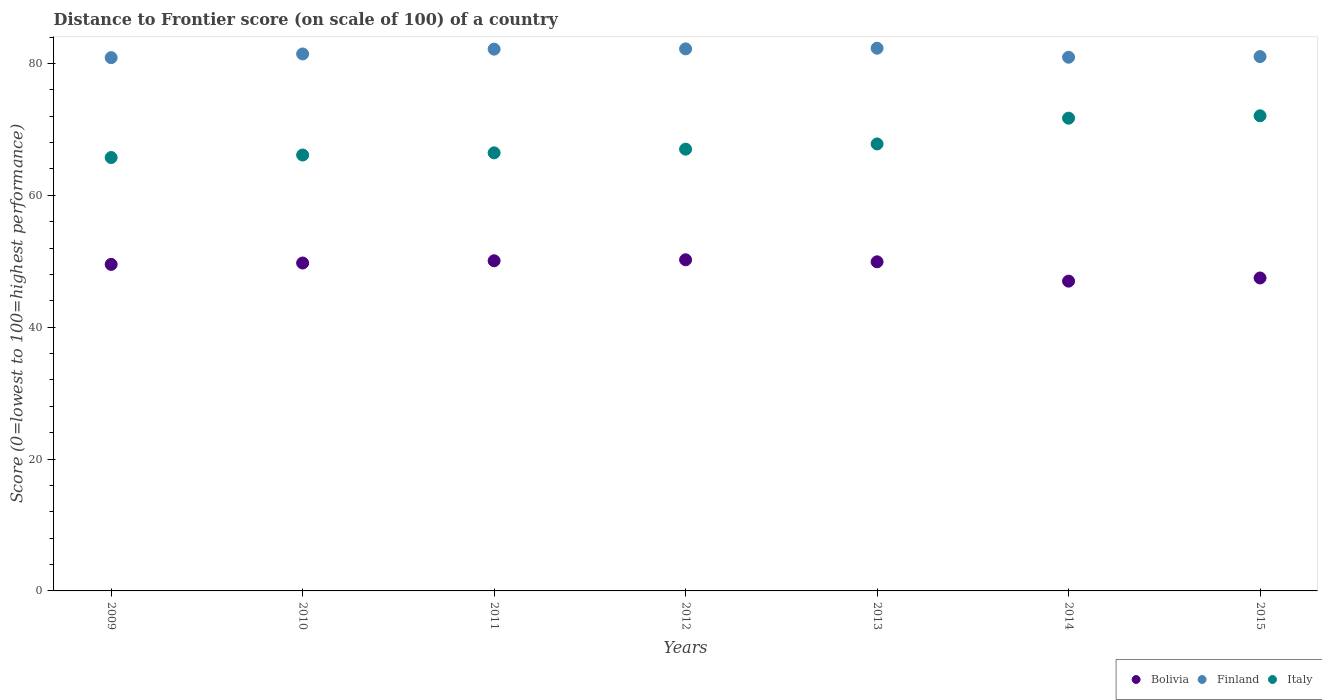What is the distance to frontier score of in Bolivia in 2010?
Make the answer very short. 49.74. Across all years, what is the maximum distance to frontier score of in Italy?
Provide a short and direct response. 72.07. Across all years, what is the minimum distance to frontier score of in Bolivia?
Provide a succinct answer. 46.99. In which year was the distance to frontier score of in Bolivia maximum?
Provide a short and direct response. 2012. In which year was the distance to frontier score of in Bolivia minimum?
Keep it short and to the point. 2014. What is the total distance to frontier score of in Italy in the graph?
Ensure brevity in your answer.  476.9. What is the difference between the distance to frontier score of in Italy in 2009 and that in 2015?
Make the answer very short. -6.33. What is the difference between the distance to frontier score of in Finland in 2012 and the distance to frontier score of in Bolivia in 2009?
Provide a short and direct response. 32.69. What is the average distance to frontier score of in Finland per year?
Keep it short and to the point. 81.58. In the year 2009, what is the difference between the distance to frontier score of in Bolivia and distance to frontier score of in Italy?
Make the answer very short. -16.21. What is the ratio of the distance to frontier score of in Italy in 2010 to that in 2014?
Provide a short and direct response. 0.92. Is the distance to frontier score of in Bolivia in 2011 less than that in 2013?
Your answer should be compact. No. Is the difference between the distance to frontier score of in Bolivia in 2009 and 2015 greater than the difference between the distance to frontier score of in Italy in 2009 and 2015?
Give a very brief answer. Yes. What is the difference between the highest and the second highest distance to frontier score of in Bolivia?
Offer a terse response. 0.15. What is the difference between the highest and the lowest distance to frontier score of in Italy?
Keep it short and to the point. 6.33. In how many years, is the distance to frontier score of in Italy greater than the average distance to frontier score of in Italy taken over all years?
Make the answer very short. 2. Is it the case that in every year, the sum of the distance to frontier score of in Finland and distance to frontier score of in Bolivia  is greater than the distance to frontier score of in Italy?
Offer a very short reply. Yes. Does the distance to frontier score of in Italy monotonically increase over the years?
Your answer should be very brief. Yes. How many dotlines are there?
Give a very brief answer. 3. How many years are there in the graph?
Provide a succinct answer. 7. What is the difference between two consecutive major ticks on the Y-axis?
Provide a succinct answer. 20. Are the values on the major ticks of Y-axis written in scientific E-notation?
Offer a terse response. No. Does the graph contain any zero values?
Your answer should be compact. No. How many legend labels are there?
Keep it short and to the point. 3. What is the title of the graph?
Your answer should be very brief. Distance to Frontier score (on scale of 100) of a country. Does "Guam" appear as one of the legend labels in the graph?
Offer a very short reply. No. What is the label or title of the X-axis?
Keep it short and to the point. Years. What is the label or title of the Y-axis?
Provide a succinct answer. Score (0=lowest to 100=highest performance). What is the Score (0=lowest to 100=highest performance) of Bolivia in 2009?
Provide a short and direct response. 49.53. What is the Score (0=lowest to 100=highest performance) of Finland in 2009?
Your response must be concise. 80.89. What is the Score (0=lowest to 100=highest performance) in Italy in 2009?
Your response must be concise. 65.74. What is the Score (0=lowest to 100=highest performance) in Bolivia in 2010?
Provide a short and direct response. 49.74. What is the Score (0=lowest to 100=highest performance) in Finland in 2010?
Your answer should be very brief. 81.45. What is the Score (0=lowest to 100=highest performance) of Italy in 2010?
Provide a succinct answer. 66.12. What is the Score (0=lowest to 100=highest performance) in Bolivia in 2011?
Your answer should be very brief. 50.08. What is the Score (0=lowest to 100=highest performance) in Finland in 2011?
Your answer should be compact. 82.18. What is the Score (0=lowest to 100=highest performance) in Italy in 2011?
Offer a terse response. 66.45. What is the Score (0=lowest to 100=highest performance) of Bolivia in 2012?
Your answer should be compact. 50.23. What is the Score (0=lowest to 100=highest performance) of Finland in 2012?
Offer a terse response. 82.22. What is the Score (0=lowest to 100=highest performance) in Italy in 2012?
Your response must be concise. 67.01. What is the Score (0=lowest to 100=highest performance) in Bolivia in 2013?
Your response must be concise. 49.92. What is the Score (0=lowest to 100=highest performance) in Finland in 2013?
Offer a very short reply. 82.32. What is the Score (0=lowest to 100=highest performance) of Italy in 2013?
Your answer should be compact. 67.8. What is the Score (0=lowest to 100=highest performance) of Bolivia in 2014?
Provide a succinct answer. 46.99. What is the Score (0=lowest to 100=highest performance) in Finland in 2014?
Offer a terse response. 80.95. What is the Score (0=lowest to 100=highest performance) of Italy in 2014?
Offer a very short reply. 71.71. What is the Score (0=lowest to 100=highest performance) of Bolivia in 2015?
Make the answer very short. 47.47. What is the Score (0=lowest to 100=highest performance) of Finland in 2015?
Your answer should be very brief. 81.05. What is the Score (0=lowest to 100=highest performance) in Italy in 2015?
Ensure brevity in your answer.  72.07. Across all years, what is the maximum Score (0=lowest to 100=highest performance) in Bolivia?
Your answer should be very brief. 50.23. Across all years, what is the maximum Score (0=lowest to 100=highest performance) in Finland?
Provide a short and direct response. 82.32. Across all years, what is the maximum Score (0=lowest to 100=highest performance) in Italy?
Ensure brevity in your answer.  72.07. Across all years, what is the minimum Score (0=lowest to 100=highest performance) of Bolivia?
Provide a succinct answer. 46.99. Across all years, what is the minimum Score (0=lowest to 100=highest performance) of Finland?
Offer a terse response. 80.89. Across all years, what is the minimum Score (0=lowest to 100=highest performance) of Italy?
Ensure brevity in your answer.  65.74. What is the total Score (0=lowest to 100=highest performance) of Bolivia in the graph?
Your response must be concise. 343.96. What is the total Score (0=lowest to 100=highest performance) of Finland in the graph?
Provide a succinct answer. 571.06. What is the total Score (0=lowest to 100=highest performance) of Italy in the graph?
Provide a short and direct response. 476.9. What is the difference between the Score (0=lowest to 100=highest performance) of Bolivia in 2009 and that in 2010?
Provide a succinct answer. -0.21. What is the difference between the Score (0=lowest to 100=highest performance) in Finland in 2009 and that in 2010?
Provide a short and direct response. -0.56. What is the difference between the Score (0=lowest to 100=highest performance) in Italy in 2009 and that in 2010?
Offer a terse response. -0.38. What is the difference between the Score (0=lowest to 100=highest performance) of Bolivia in 2009 and that in 2011?
Offer a very short reply. -0.55. What is the difference between the Score (0=lowest to 100=highest performance) in Finland in 2009 and that in 2011?
Offer a very short reply. -1.29. What is the difference between the Score (0=lowest to 100=highest performance) in Italy in 2009 and that in 2011?
Make the answer very short. -0.71. What is the difference between the Score (0=lowest to 100=highest performance) of Finland in 2009 and that in 2012?
Your answer should be compact. -1.33. What is the difference between the Score (0=lowest to 100=highest performance) of Italy in 2009 and that in 2012?
Your answer should be very brief. -1.27. What is the difference between the Score (0=lowest to 100=highest performance) in Bolivia in 2009 and that in 2013?
Ensure brevity in your answer.  -0.39. What is the difference between the Score (0=lowest to 100=highest performance) in Finland in 2009 and that in 2013?
Give a very brief answer. -1.43. What is the difference between the Score (0=lowest to 100=highest performance) in Italy in 2009 and that in 2013?
Provide a short and direct response. -2.06. What is the difference between the Score (0=lowest to 100=highest performance) in Bolivia in 2009 and that in 2014?
Your answer should be compact. 2.54. What is the difference between the Score (0=lowest to 100=highest performance) of Finland in 2009 and that in 2014?
Give a very brief answer. -0.06. What is the difference between the Score (0=lowest to 100=highest performance) in Italy in 2009 and that in 2014?
Keep it short and to the point. -5.97. What is the difference between the Score (0=lowest to 100=highest performance) in Bolivia in 2009 and that in 2015?
Provide a succinct answer. 2.06. What is the difference between the Score (0=lowest to 100=highest performance) of Finland in 2009 and that in 2015?
Ensure brevity in your answer.  -0.16. What is the difference between the Score (0=lowest to 100=highest performance) in Italy in 2009 and that in 2015?
Make the answer very short. -6.33. What is the difference between the Score (0=lowest to 100=highest performance) in Bolivia in 2010 and that in 2011?
Ensure brevity in your answer.  -0.34. What is the difference between the Score (0=lowest to 100=highest performance) in Finland in 2010 and that in 2011?
Your answer should be very brief. -0.73. What is the difference between the Score (0=lowest to 100=highest performance) of Italy in 2010 and that in 2011?
Keep it short and to the point. -0.33. What is the difference between the Score (0=lowest to 100=highest performance) of Bolivia in 2010 and that in 2012?
Ensure brevity in your answer.  -0.49. What is the difference between the Score (0=lowest to 100=highest performance) in Finland in 2010 and that in 2012?
Your response must be concise. -0.77. What is the difference between the Score (0=lowest to 100=highest performance) in Italy in 2010 and that in 2012?
Keep it short and to the point. -0.89. What is the difference between the Score (0=lowest to 100=highest performance) in Bolivia in 2010 and that in 2013?
Your answer should be very brief. -0.18. What is the difference between the Score (0=lowest to 100=highest performance) of Finland in 2010 and that in 2013?
Your answer should be very brief. -0.87. What is the difference between the Score (0=lowest to 100=highest performance) in Italy in 2010 and that in 2013?
Make the answer very short. -1.68. What is the difference between the Score (0=lowest to 100=highest performance) in Bolivia in 2010 and that in 2014?
Offer a terse response. 2.75. What is the difference between the Score (0=lowest to 100=highest performance) in Italy in 2010 and that in 2014?
Keep it short and to the point. -5.59. What is the difference between the Score (0=lowest to 100=highest performance) in Bolivia in 2010 and that in 2015?
Your response must be concise. 2.27. What is the difference between the Score (0=lowest to 100=highest performance) of Italy in 2010 and that in 2015?
Provide a succinct answer. -5.95. What is the difference between the Score (0=lowest to 100=highest performance) of Bolivia in 2011 and that in 2012?
Your answer should be compact. -0.15. What is the difference between the Score (0=lowest to 100=highest performance) in Finland in 2011 and that in 2012?
Provide a short and direct response. -0.04. What is the difference between the Score (0=lowest to 100=highest performance) of Italy in 2011 and that in 2012?
Give a very brief answer. -0.56. What is the difference between the Score (0=lowest to 100=highest performance) of Bolivia in 2011 and that in 2013?
Make the answer very short. 0.16. What is the difference between the Score (0=lowest to 100=highest performance) in Finland in 2011 and that in 2013?
Offer a very short reply. -0.14. What is the difference between the Score (0=lowest to 100=highest performance) in Italy in 2011 and that in 2013?
Your answer should be very brief. -1.35. What is the difference between the Score (0=lowest to 100=highest performance) in Bolivia in 2011 and that in 2014?
Your answer should be very brief. 3.09. What is the difference between the Score (0=lowest to 100=highest performance) in Finland in 2011 and that in 2014?
Provide a succinct answer. 1.23. What is the difference between the Score (0=lowest to 100=highest performance) in Italy in 2011 and that in 2014?
Make the answer very short. -5.26. What is the difference between the Score (0=lowest to 100=highest performance) in Bolivia in 2011 and that in 2015?
Give a very brief answer. 2.61. What is the difference between the Score (0=lowest to 100=highest performance) of Finland in 2011 and that in 2015?
Keep it short and to the point. 1.13. What is the difference between the Score (0=lowest to 100=highest performance) of Italy in 2011 and that in 2015?
Provide a succinct answer. -5.62. What is the difference between the Score (0=lowest to 100=highest performance) in Bolivia in 2012 and that in 2013?
Your response must be concise. 0.31. What is the difference between the Score (0=lowest to 100=highest performance) in Italy in 2012 and that in 2013?
Make the answer very short. -0.79. What is the difference between the Score (0=lowest to 100=highest performance) in Bolivia in 2012 and that in 2014?
Your answer should be very brief. 3.24. What is the difference between the Score (0=lowest to 100=highest performance) in Finland in 2012 and that in 2014?
Provide a succinct answer. 1.27. What is the difference between the Score (0=lowest to 100=highest performance) of Italy in 2012 and that in 2014?
Offer a very short reply. -4.7. What is the difference between the Score (0=lowest to 100=highest performance) of Bolivia in 2012 and that in 2015?
Your answer should be very brief. 2.76. What is the difference between the Score (0=lowest to 100=highest performance) of Finland in 2012 and that in 2015?
Provide a short and direct response. 1.17. What is the difference between the Score (0=lowest to 100=highest performance) in Italy in 2012 and that in 2015?
Offer a very short reply. -5.06. What is the difference between the Score (0=lowest to 100=highest performance) in Bolivia in 2013 and that in 2014?
Give a very brief answer. 2.93. What is the difference between the Score (0=lowest to 100=highest performance) in Finland in 2013 and that in 2014?
Your answer should be compact. 1.37. What is the difference between the Score (0=lowest to 100=highest performance) of Italy in 2013 and that in 2014?
Your response must be concise. -3.91. What is the difference between the Score (0=lowest to 100=highest performance) in Bolivia in 2013 and that in 2015?
Provide a short and direct response. 2.45. What is the difference between the Score (0=lowest to 100=highest performance) in Finland in 2013 and that in 2015?
Provide a succinct answer. 1.27. What is the difference between the Score (0=lowest to 100=highest performance) in Italy in 2013 and that in 2015?
Keep it short and to the point. -4.27. What is the difference between the Score (0=lowest to 100=highest performance) in Bolivia in 2014 and that in 2015?
Provide a short and direct response. -0.48. What is the difference between the Score (0=lowest to 100=highest performance) in Finland in 2014 and that in 2015?
Your response must be concise. -0.1. What is the difference between the Score (0=lowest to 100=highest performance) of Italy in 2014 and that in 2015?
Your response must be concise. -0.36. What is the difference between the Score (0=lowest to 100=highest performance) in Bolivia in 2009 and the Score (0=lowest to 100=highest performance) in Finland in 2010?
Offer a terse response. -31.92. What is the difference between the Score (0=lowest to 100=highest performance) in Bolivia in 2009 and the Score (0=lowest to 100=highest performance) in Italy in 2010?
Your answer should be compact. -16.59. What is the difference between the Score (0=lowest to 100=highest performance) of Finland in 2009 and the Score (0=lowest to 100=highest performance) of Italy in 2010?
Offer a very short reply. 14.77. What is the difference between the Score (0=lowest to 100=highest performance) of Bolivia in 2009 and the Score (0=lowest to 100=highest performance) of Finland in 2011?
Provide a short and direct response. -32.65. What is the difference between the Score (0=lowest to 100=highest performance) of Bolivia in 2009 and the Score (0=lowest to 100=highest performance) of Italy in 2011?
Give a very brief answer. -16.92. What is the difference between the Score (0=lowest to 100=highest performance) of Finland in 2009 and the Score (0=lowest to 100=highest performance) of Italy in 2011?
Provide a short and direct response. 14.44. What is the difference between the Score (0=lowest to 100=highest performance) of Bolivia in 2009 and the Score (0=lowest to 100=highest performance) of Finland in 2012?
Your answer should be very brief. -32.69. What is the difference between the Score (0=lowest to 100=highest performance) of Bolivia in 2009 and the Score (0=lowest to 100=highest performance) of Italy in 2012?
Make the answer very short. -17.48. What is the difference between the Score (0=lowest to 100=highest performance) in Finland in 2009 and the Score (0=lowest to 100=highest performance) in Italy in 2012?
Provide a succinct answer. 13.88. What is the difference between the Score (0=lowest to 100=highest performance) in Bolivia in 2009 and the Score (0=lowest to 100=highest performance) in Finland in 2013?
Your response must be concise. -32.79. What is the difference between the Score (0=lowest to 100=highest performance) of Bolivia in 2009 and the Score (0=lowest to 100=highest performance) of Italy in 2013?
Provide a succinct answer. -18.27. What is the difference between the Score (0=lowest to 100=highest performance) in Finland in 2009 and the Score (0=lowest to 100=highest performance) in Italy in 2013?
Keep it short and to the point. 13.09. What is the difference between the Score (0=lowest to 100=highest performance) in Bolivia in 2009 and the Score (0=lowest to 100=highest performance) in Finland in 2014?
Provide a succinct answer. -31.42. What is the difference between the Score (0=lowest to 100=highest performance) of Bolivia in 2009 and the Score (0=lowest to 100=highest performance) of Italy in 2014?
Offer a very short reply. -22.18. What is the difference between the Score (0=lowest to 100=highest performance) in Finland in 2009 and the Score (0=lowest to 100=highest performance) in Italy in 2014?
Offer a terse response. 9.18. What is the difference between the Score (0=lowest to 100=highest performance) in Bolivia in 2009 and the Score (0=lowest to 100=highest performance) in Finland in 2015?
Provide a short and direct response. -31.52. What is the difference between the Score (0=lowest to 100=highest performance) of Bolivia in 2009 and the Score (0=lowest to 100=highest performance) of Italy in 2015?
Make the answer very short. -22.54. What is the difference between the Score (0=lowest to 100=highest performance) of Finland in 2009 and the Score (0=lowest to 100=highest performance) of Italy in 2015?
Ensure brevity in your answer.  8.82. What is the difference between the Score (0=lowest to 100=highest performance) in Bolivia in 2010 and the Score (0=lowest to 100=highest performance) in Finland in 2011?
Provide a succinct answer. -32.44. What is the difference between the Score (0=lowest to 100=highest performance) of Bolivia in 2010 and the Score (0=lowest to 100=highest performance) of Italy in 2011?
Ensure brevity in your answer.  -16.71. What is the difference between the Score (0=lowest to 100=highest performance) in Bolivia in 2010 and the Score (0=lowest to 100=highest performance) in Finland in 2012?
Your answer should be compact. -32.48. What is the difference between the Score (0=lowest to 100=highest performance) of Bolivia in 2010 and the Score (0=lowest to 100=highest performance) of Italy in 2012?
Your answer should be very brief. -17.27. What is the difference between the Score (0=lowest to 100=highest performance) in Finland in 2010 and the Score (0=lowest to 100=highest performance) in Italy in 2012?
Ensure brevity in your answer.  14.44. What is the difference between the Score (0=lowest to 100=highest performance) in Bolivia in 2010 and the Score (0=lowest to 100=highest performance) in Finland in 2013?
Your answer should be compact. -32.58. What is the difference between the Score (0=lowest to 100=highest performance) of Bolivia in 2010 and the Score (0=lowest to 100=highest performance) of Italy in 2013?
Provide a short and direct response. -18.06. What is the difference between the Score (0=lowest to 100=highest performance) in Finland in 2010 and the Score (0=lowest to 100=highest performance) in Italy in 2013?
Offer a terse response. 13.65. What is the difference between the Score (0=lowest to 100=highest performance) in Bolivia in 2010 and the Score (0=lowest to 100=highest performance) in Finland in 2014?
Your answer should be very brief. -31.21. What is the difference between the Score (0=lowest to 100=highest performance) of Bolivia in 2010 and the Score (0=lowest to 100=highest performance) of Italy in 2014?
Give a very brief answer. -21.97. What is the difference between the Score (0=lowest to 100=highest performance) of Finland in 2010 and the Score (0=lowest to 100=highest performance) of Italy in 2014?
Ensure brevity in your answer.  9.74. What is the difference between the Score (0=lowest to 100=highest performance) in Bolivia in 2010 and the Score (0=lowest to 100=highest performance) in Finland in 2015?
Offer a very short reply. -31.31. What is the difference between the Score (0=lowest to 100=highest performance) in Bolivia in 2010 and the Score (0=lowest to 100=highest performance) in Italy in 2015?
Make the answer very short. -22.33. What is the difference between the Score (0=lowest to 100=highest performance) in Finland in 2010 and the Score (0=lowest to 100=highest performance) in Italy in 2015?
Your answer should be very brief. 9.38. What is the difference between the Score (0=lowest to 100=highest performance) of Bolivia in 2011 and the Score (0=lowest to 100=highest performance) of Finland in 2012?
Offer a terse response. -32.14. What is the difference between the Score (0=lowest to 100=highest performance) of Bolivia in 2011 and the Score (0=lowest to 100=highest performance) of Italy in 2012?
Your answer should be compact. -16.93. What is the difference between the Score (0=lowest to 100=highest performance) of Finland in 2011 and the Score (0=lowest to 100=highest performance) of Italy in 2012?
Keep it short and to the point. 15.17. What is the difference between the Score (0=lowest to 100=highest performance) in Bolivia in 2011 and the Score (0=lowest to 100=highest performance) in Finland in 2013?
Your answer should be compact. -32.24. What is the difference between the Score (0=lowest to 100=highest performance) of Bolivia in 2011 and the Score (0=lowest to 100=highest performance) of Italy in 2013?
Give a very brief answer. -17.72. What is the difference between the Score (0=lowest to 100=highest performance) in Finland in 2011 and the Score (0=lowest to 100=highest performance) in Italy in 2013?
Offer a terse response. 14.38. What is the difference between the Score (0=lowest to 100=highest performance) in Bolivia in 2011 and the Score (0=lowest to 100=highest performance) in Finland in 2014?
Offer a very short reply. -30.87. What is the difference between the Score (0=lowest to 100=highest performance) in Bolivia in 2011 and the Score (0=lowest to 100=highest performance) in Italy in 2014?
Provide a succinct answer. -21.63. What is the difference between the Score (0=lowest to 100=highest performance) of Finland in 2011 and the Score (0=lowest to 100=highest performance) of Italy in 2014?
Offer a terse response. 10.47. What is the difference between the Score (0=lowest to 100=highest performance) of Bolivia in 2011 and the Score (0=lowest to 100=highest performance) of Finland in 2015?
Ensure brevity in your answer.  -30.97. What is the difference between the Score (0=lowest to 100=highest performance) of Bolivia in 2011 and the Score (0=lowest to 100=highest performance) of Italy in 2015?
Offer a terse response. -21.99. What is the difference between the Score (0=lowest to 100=highest performance) in Finland in 2011 and the Score (0=lowest to 100=highest performance) in Italy in 2015?
Your answer should be compact. 10.11. What is the difference between the Score (0=lowest to 100=highest performance) of Bolivia in 2012 and the Score (0=lowest to 100=highest performance) of Finland in 2013?
Your answer should be very brief. -32.09. What is the difference between the Score (0=lowest to 100=highest performance) of Bolivia in 2012 and the Score (0=lowest to 100=highest performance) of Italy in 2013?
Ensure brevity in your answer.  -17.57. What is the difference between the Score (0=lowest to 100=highest performance) in Finland in 2012 and the Score (0=lowest to 100=highest performance) in Italy in 2013?
Make the answer very short. 14.42. What is the difference between the Score (0=lowest to 100=highest performance) in Bolivia in 2012 and the Score (0=lowest to 100=highest performance) in Finland in 2014?
Provide a succinct answer. -30.72. What is the difference between the Score (0=lowest to 100=highest performance) in Bolivia in 2012 and the Score (0=lowest to 100=highest performance) in Italy in 2014?
Ensure brevity in your answer.  -21.48. What is the difference between the Score (0=lowest to 100=highest performance) in Finland in 2012 and the Score (0=lowest to 100=highest performance) in Italy in 2014?
Your response must be concise. 10.51. What is the difference between the Score (0=lowest to 100=highest performance) in Bolivia in 2012 and the Score (0=lowest to 100=highest performance) in Finland in 2015?
Your response must be concise. -30.82. What is the difference between the Score (0=lowest to 100=highest performance) in Bolivia in 2012 and the Score (0=lowest to 100=highest performance) in Italy in 2015?
Provide a succinct answer. -21.84. What is the difference between the Score (0=lowest to 100=highest performance) in Finland in 2012 and the Score (0=lowest to 100=highest performance) in Italy in 2015?
Offer a very short reply. 10.15. What is the difference between the Score (0=lowest to 100=highest performance) of Bolivia in 2013 and the Score (0=lowest to 100=highest performance) of Finland in 2014?
Offer a very short reply. -31.03. What is the difference between the Score (0=lowest to 100=highest performance) of Bolivia in 2013 and the Score (0=lowest to 100=highest performance) of Italy in 2014?
Ensure brevity in your answer.  -21.79. What is the difference between the Score (0=lowest to 100=highest performance) in Finland in 2013 and the Score (0=lowest to 100=highest performance) in Italy in 2014?
Your response must be concise. 10.61. What is the difference between the Score (0=lowest to 100=highest performance) of Bolivia in 2013 and the Score (0=lowest to 100=highest performance) of Finland in 2015?
Your answer should be very brief. -31.13. What is the difference between the Score (0=lowest to 100=highest performance) of Bolivia in 2013 and the Score (0=lowest to 100=highest performance) of Italy in 2015?
Ensure brevity in your answer.  -22.15. What is the difference between the Score (0=lowest to 100=highest performance) of Finland in 2013 and the Score (0=lowest to 100=highest performance) of Italy in 2015?
Give a very brief answer. 10.25. What is the difference between the Score (0=lowest to 100=highest performance) of Bolivia in 2014 and the Score (0=lowest to 100=highest performance) of Finland in 2015?
Your answer should be very brief. -34.06. What is the difference between the Score (0=lowest to 100=highest performance) in Bolivia in 2014 and the Score (0=lowest to 100=highest performance) in Italy in 2015?
Keep it short and to the point. -25.08. What is the difference between the Score (0=lowest to 100=highest performance) in Finland in 2014 and the Score (0=lowest to 100=highest performance) in Italy in 2015?
Give a very brief answer. 8.88. What is the average Score (0=lowest to 100=highest performance) in Bolivia per year?
Your response must be concise. 49.14. What is the average Score (0=lowest to 100=highest performance) of Finland per year?
Offer a very short reply. 81.58. What is the average Score (0=lowest to 100=highest performance) in Italy per year?
Give a very brief answer. 68.13. In the year 2009, what is the difference between the Score (0=lowest to 100=highest performance) in Bolivia and Score (0=lowest to 100=highest performance) in Finland?
Make the answer very short. -31.36. In the year 2009, what is the difference between the Score (0=lowest to 100=highest performance) in Bolivia and Score (0=lowest to 100=highest performance) in Italy?
Ensure brevity in your answer.  -16.21. In the year 2009, what is the difference between the Score (0=lowest to 100=highest performance) of Finland and Score (0=lowest to 100=highest performance) of Italy?
Provide a succinct answer. 15.15. In the year 2010, what is the difference between the Score (0=lowest to 100=highest performance) in Bolivia and Score (0=lowest to 100=highest performance) in Finland?
Give a very brief answer. -31.71. In the year 2010, what is the difference between the Score (0=lowest to 100=highest performance) of Bolivia and Score (0=lowest to 100=highest performance) of Italy?
Provide a short and direct response. -16.38. In the year 2010, what is the difference between the Score (0=lowest to 100=highest performance) in Finland and Score (0=lowest to 100=highest performance) in Italy?
Give a very brief answer. 15.33. In the year 2011, what is the difference between the Score (0=lowest to 100=highest performance) of Bolivia and Score (0=lowest to 100=highest performance) of Finland?
Give a very brief answer. -32.1. In the year 2011, what is the difference between the Score (0=lowest to 100=highest performance) in Bolivia and Score (0=lowest to 100=highest performance) in Italy?
Offer a terse response. -16.37. In the year 2011, what is the difference between the Score (0=lowest to 100=highest performance) in Finland and Score (0=lowest to 100=highest performance) in Italy?
Give a very brief answer. 15.73. In the year 2012, what is the difference between the Score (0=lowest to 100=highest performance) in Bolivia and Score (0=lowest to 100=highest performance) in Finland?
Your response must be concise. -31.99. In the year 2012, what is the difference between the Score (0=lowest to 100=highest performance) of Bolivia and Score (0=lowest to 100=highest performance) of Italy?
Your answer should be compact. -16.78. In the year 2012, what is the difference between the Score (0=lowest to 100=highest performance) in Finland and Score (0=lowest to 100=highest performance) in Italy?
Offer a very short reply. 15.21. In the year 2013, what is the difference between the Score (0=lowest to 100=highest performance) of Bolivia and Score (0=lowest to 100=highest performance) of Finland?
Offer a terse response. -32.4. In the year 2013, what is the difference between the Score (0=lowest to 100=highest performance) in Bolivia and Score (0=lowest to 100=highest performance) in Italy?
Give a very brief answer. -17.88. In the year 2013, what is the difference between the Score (0=lowest to 100=highest performance) in Finland and Score (0=lowest to 100=highest performance) in Italy?
Offer a very short reply. 14.52. In the year 2014, what is the difference between the Score (0=lowest to 100=highest performance) in Bolivia and Score (0=lowest to 100=highest performance) in Finland?
Give a very brief answer. -33.96. In the year 2014, what is the difference between the Score (0=lowest to 100=highest performance) of Bolivia and Score (0=lowest to 100=highest performance) of Italy?
Make the answer very short. -24.72. In the year 2014, what is the difference between the Score (0=lowest to 100=highest performance) of Finland and Score (0=lowest to 100=highest performance) of Italy?
Offer a very short reply. 9.24. In the year 2015, what is the difference between the Score (0=lowest to 100=highest performance) in Bolivia and Score (0=lowest to 100=highest performance) in Finland?
Give a very brief answer. -33.58. In the year 2015, what is the difference between the Score (0=lowest to 100=highest performance) in Bolivia and Score (0=lowest to 100=highest performance) in Italy?
Your answer should be very brief. -24.6. In the year 2015, what is the difference between the Score (0=lowest to 100=highest performance) in Finland and Score (0=lowest to 100=highest performance) in Italy?
Your response must be concise. 8.98. What is the ratio of the Score (0=lowest to 100=highest performance) of Italy in 2009 to that in 2010?
Your response must be concise. 0.99. What is the ratio of the Score (0=lowest to 100=highest performance) of Bolivia in 2009 to that in 2011?
Ensure brevity in your answer.  0.99. What is the ratio of the Score (0=lowest to 100=highest performance) in Finland in 2009 to that in 2011?
Offer a very short reply. 0.98. What is the ratio of the Score (0=lowest to 100=highest performance) of Italy in 2009 to that in 2011?
Your answer should be very brief. 0.99. What is the ratio of the Score (0=lowest to 100=highest performance) of Bolivia in 2009 to that in 2012?
Offer a very short reply. 0.99. What is the ratio of the Score (0=lowest to 100=highest performance) of Finland in 2009 to that in 2012?
Ensure brevity in your answer.  0.98. What is the ratio of the Score (0=lowest to 100=highest performance) in Italy in 2009 to that in 2012?
Ensure brevity in your answer.  0.98. What is the ratio of the Score (0=lowest to 100=highest performance) of Finland in 2009 to that in 2013?
Offer a very short reply. 0.98. What is the ratio of the Score (0=lowest to 100=highest performance) of Italy in 2009 to that in 2013?
Ensure brevity in your answer.  0.97. What is the ratio of the Score (0=lowest to 100=highest performance) in Bolivia in 2009 to that in 2014?
Offer a very short reply. 1.05. What is the ratio of the Score (0=lowest to 100=highest performance) of Finland in 2009 to that in 2014?
Ensure brevity in your answer.  1. What is the ratio of the Score (0=lowest to 100=highest performance) in Bolivia in 2009 to that in 2015?
Offer a terse response. 1.04. What is the ratio of the Score (0=lowest to 100=highest performance) in Italy in 2009 to that in 2015?
Give a very brief answer. 0.91. What is the ratio of the Score (0=lowest to 100=highest performance) in Italy in 2010 to that in 2011?
Provide a short and direct response. 0.99. What is the ratio of the Score (0=lowest to 100=highest performance) in Bolivia in 2010 to that in 2012?
Offer a very short reply. 0.99. What is the ratio of the Score (0=lowest to 100=highest performance) in Finland in 2010 to that in 2012?
Make the answer very short. 0.99. What is the ratio of the Score (0=lowest to 100=highest performance) of Italy in 2010 to that in 2012?
Your answer should be very brief. 0.99. What is the ratio of the Score (0=lowest to 100=highest performance) in Bolivia in 2010 to that in 2013?
Make the answer very short. 1. What is the ratio of the Score (0=lowest to 100=highest performance) of Finland in 2010 to that in 2013?
Provide a short and direct response. 0.99. What is the ratio of the Score (0=lowest to 100=highest performance) of Italy in 2010 to that in 2013?
Keep it short and to the point. 0.98. What is the ratio of the Score (0=lowest to 100=highest performance) of Bolivia in 2010 to that in 2014?
Offer a very short reply. 1.06. What is the ratio of the Score (0=lowest to 100=highest performance) in Finland in 2010 to that in 2014?
Your answer should be compact. 1.01. What is the ratio of the Score (0=lowest to 100=highest performance) of Italy in 2010 to that in 2014?
Give a very brief answer. 0.92. What is the ratio of the Score (0=lowest to 100=highest performance) in Bolivia in 2010 to that in 2015?
Give a very brief answer. 1.05. What is the ratio of the Score (0=lowest to 100=highest performance) of Italy in 2010 to that in 2015?
Your response must be concise. 0.92. What is the ratio of the Score (0=lowest to 100=highest performance) of Bolivia in 2011 to that in 2013?
Offer a terse response. 1. What is the ratio of the Score (0=lowest to 100=highest performance) of Finland in 2011 to that in 2013?
Keep it short and to the point. 1. What is the ratio of the Score (0=lowest to 100=highest performance) in Italy in 2011 to that in 2013?
Provide a short and direct response. 0.98. What is the ratio of the Score (0=lowest to 100=highest performance) in Bolivia in 2011 to that in 2014?
Offer a very short reply. 1.07. What is the ratio of the Score (0=lowest to 100=highest performance) of Finland in 2011 to that in 2014?
Offer a very short reply. 1.02. What is the ratio of the Score (0=lowest to 100=highest performance) in Italy in 2011 to that in 2014?
Your answer should be compact. 0.93. What is the ratio of the Score (0=lowest to 100=highest performance) of Bolivia in 2011 to that in 2015?
Offer a terse response. 1.05. What is the ratio of the Score (0=lowest to 100=highest performance) of Finland in 2011 to that in 2015?
Provide a short and direct response. 1.01. What is the ratio of the Score (0=lowest to 100=highest performance) in Italy in 2011 to that in 2015?
Offer a very short reply. 0.92. What is the ratio of the Score (0=lowest to 100=highest performance) of Finland in 2012 to that in 2013?
Give a very brief answer. 1. What is the ratio of the Score (0=lowest to 100=highest performance) in Italy in 2012 to that in 2013?
Offer a terse response. 0.99. What is the ratio of the Score (0=lowest to 100=highest performance) in Bolivia in 2012 to that in 2014?
Keep it short and to the point. 1.07. What is the ratio of the Score (0=lowest to 100=highest performance) of Finland in 2012 to that in 2014?
Give a very brief answer. 1.02. What is the ratio of the Score (0=lowest to 100=highest performance) in Italy in 2012 to that in 2014?
Give a very brief answer. 0.93. What is the ratio of the Score (0=lowest to 100=highest performance) of Bolivia in 2012 to that in 2015?
Ensure brevity in your answer.  1.06. What is the ratio of the Score (0=lowest to 100=highest performance) of Finland in 2012 to that in 2015?
Keep it short and to the point. 1.01. What is the ratio of the Score (0=lowest to 100=highest performance) of Italy in 2012 to that in 2015?
Provide a short and direct response. 0.93. What is the ratio of the Score (0=lowest to 100=highest performance) in Bolivia in 2013 to that in 2014?
Provide a short and direct response. 1.06. What is the ratio of the Score (0=lowest to 100=highest performance) of Finland in 2013 to that in 2014?
Ensure brevity in your answer.  1.02. What is the ratio of the Score (0=lowest to 100=highest performance) in Italy in 2013 to that in 2014?
Ensure brevity in your answer.  0.95. What is the ratio of the Score (0=lowest to 100=highest performance) in Bolivia in 2013 to that in 2015?
Keep it short and to the point. 1.05. What is the ratio of the Score (0=lowest to 100=highest performance) of Finland in 2013 to that in 2015?
Your answer should be very brief. 1.02. What is the ratio of the Score (0=lowest to 100=highest performance) in Italy in 2013 to that in 2015?
Your answer should be compact. 0.94. What is the ratio of the Score (0=lowest to 100=highest performance) in Italy in 2014 to that in 2015?
Offer a terse response. 0.99. What is the difference between the highest and the second highest Score (0=lowest to 100=highest performance) in Bolivia?
Offer a very short reply. 0.15. What is the difference between the highest and the second highest Score (0=lowest to 100=highest performance) of Italy?
Provide a succinct answer. 0.36. What is the difference between the highest and the lowest Score (0=lowest to 100=highest performance) in Bolivia?
Your answer should be compact. 3.24. What is the difference between the highest and the lowest Score (0=lowest to 100=highest performance) in Finland?
Your response must be concise. 1.43. What is the difference between the highest and the lowest Score (0=lowest to 100=highest performance) in Italy?
Ensure brevity in your answer.  6.33. 